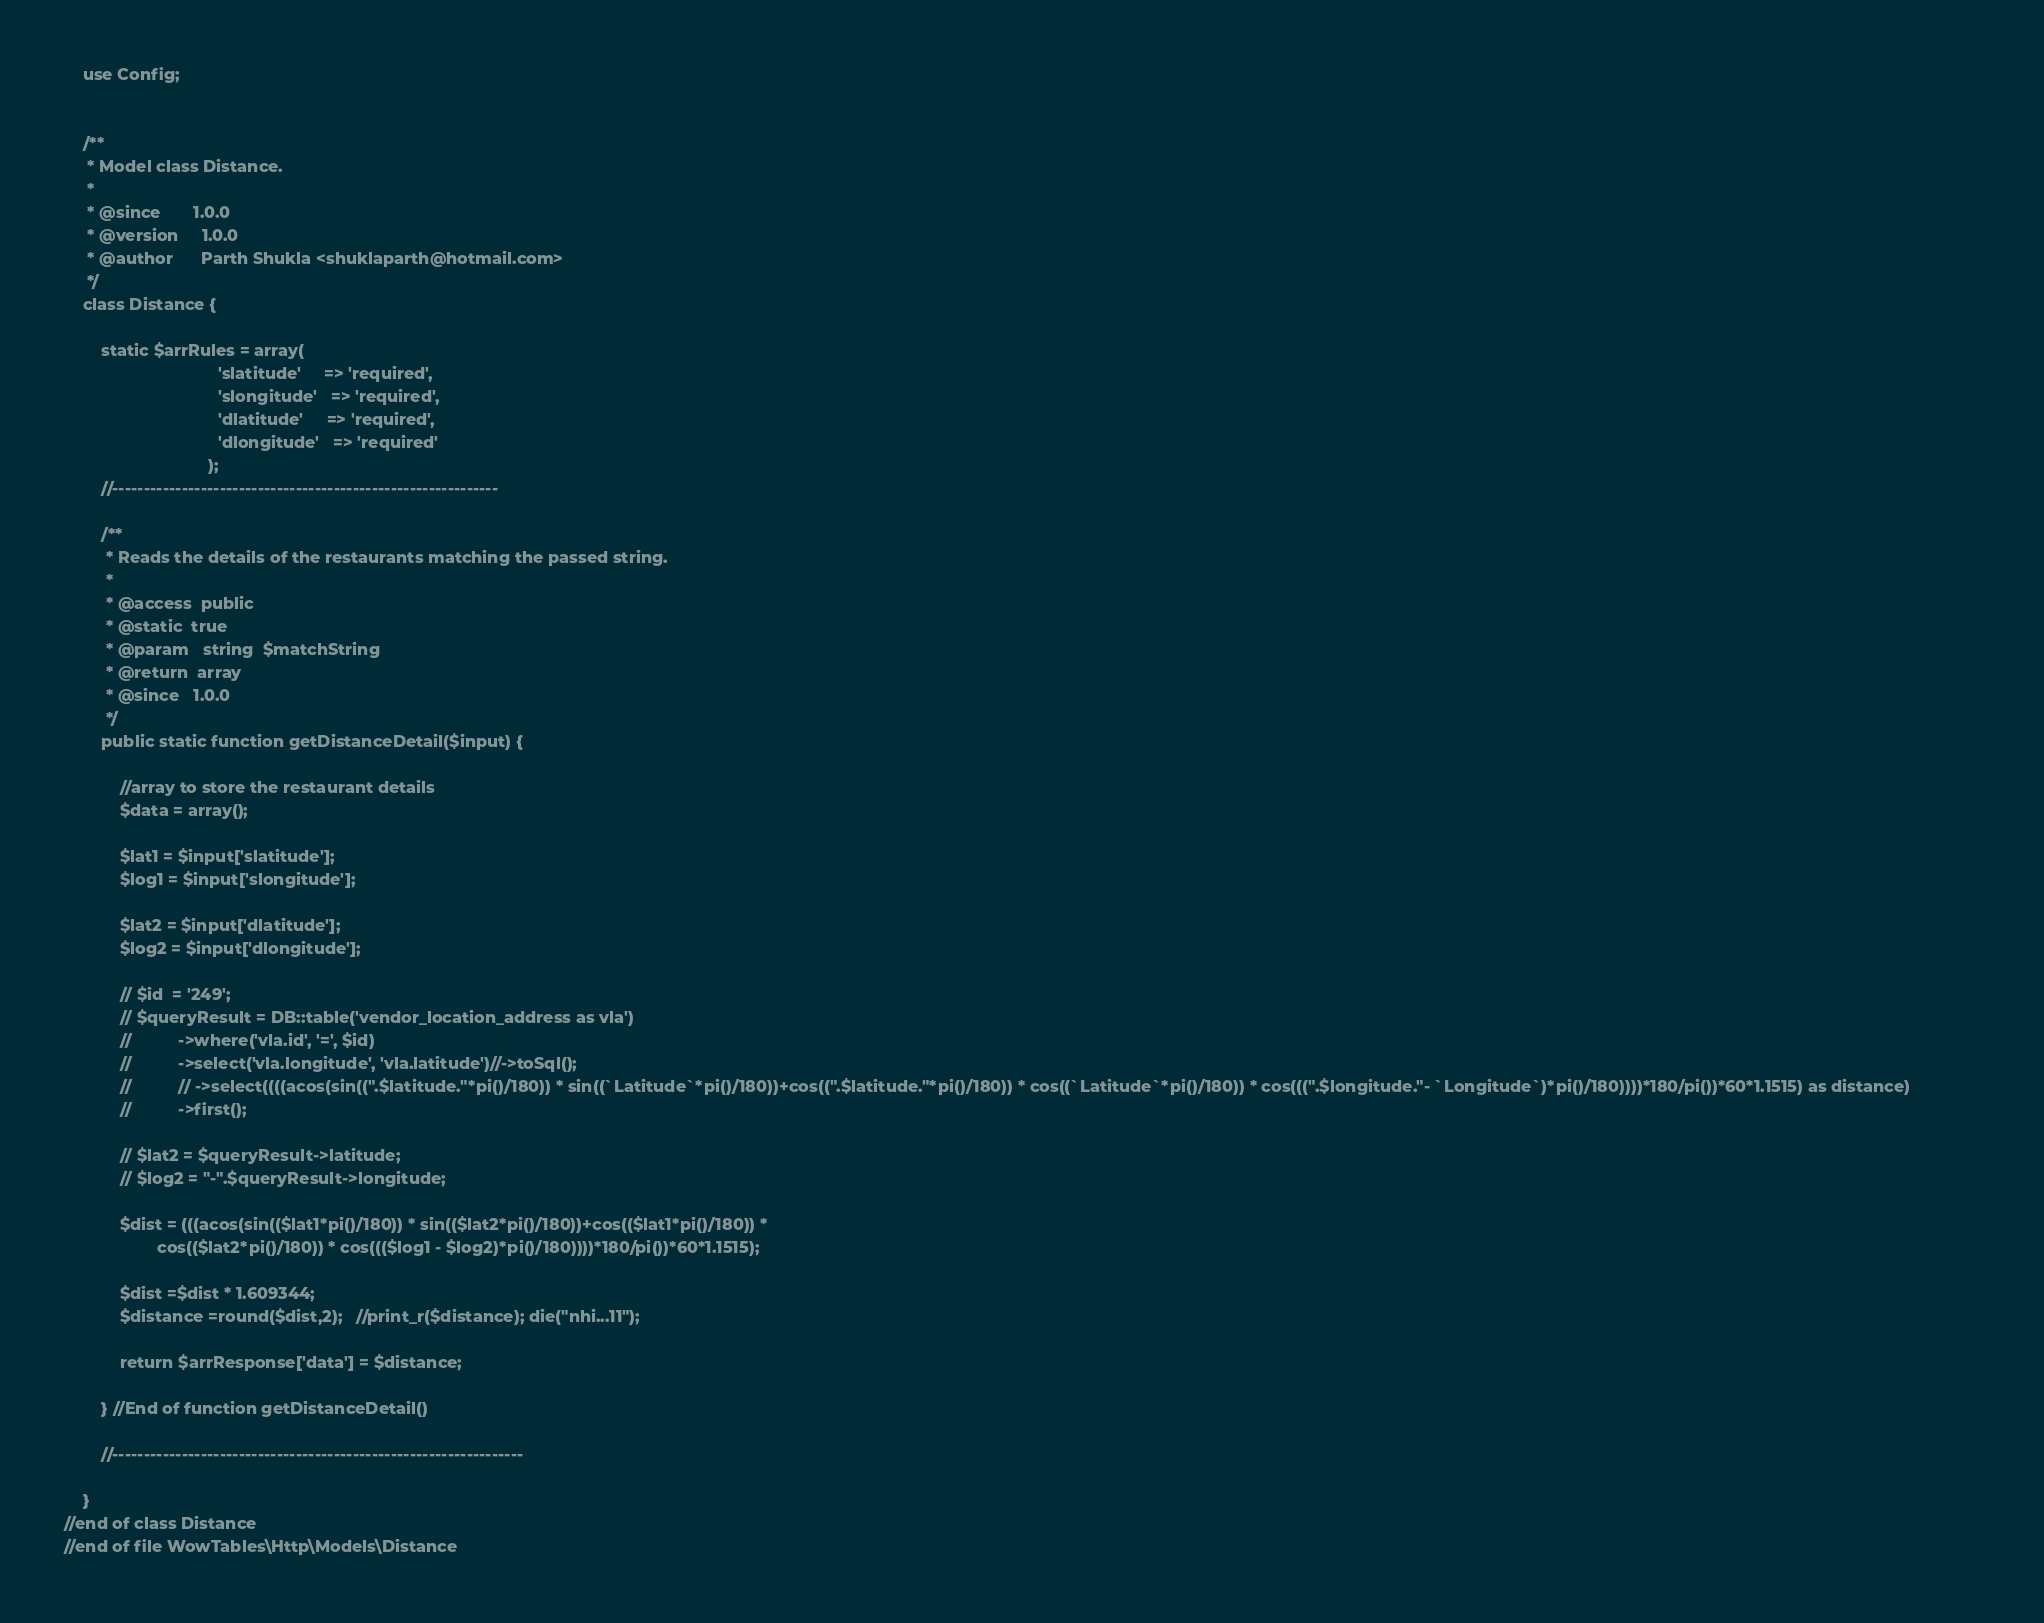Convert code to text. <code><loc_0><loc_0><loc_500><loc_500><_PHP_>	use Config;
	

	/**
	 * Model class Distance.
	 *
	 * @since		1.0.0
	 * @version		1.0.0
	 * @author		Parth Shukla <shuklaparth@hotmail.com>
	 */
	class Distance {

		static $arrRules = array(                            
	                             'slatitude'     => 'required',
	                             'slongitude'  	=> 'required',
	                             'dlatitude'     => 'required',
	                             'dlongitude'  	=> 'required'
	                           );
    	//-------------------------------------------------------------

		/**
		 * Reads the details of the restaurants matching the passed string.
		 * 
		 * @access	public
		 * @static	true
		 * @param	string	$matchString
		 * @return	array
		 * @since	1.0.0
		 */
		public static function getDistanceDetail($input) {
			
			//array to store the restaurant details
			$data = array();

			$lat1 = $input['slatitude'];
			$log1 = $input['slongitude'];

			$lat2 = $input['dlatitude'];
			$log2 = $input['dlongitude'];

			// $id  = '249';
			// $queryResult = DB::table('vendor_location_address as vla')
			// 			->where('vla.id', '=', $id)
			// 			->select('vla.longitude', 'vla.latitude')//->toSql();
			// 			// ->select((((acos(sin((".$latitude."*pi()/180)) * sin((`Latitude`*pi()/180))+cos((".$latitude."*pi()/180)) * cos((`Latitude`*pi()/180)) * cos(((".$longitude."- `Longitude`)*pi()/180))))*180/pi())*60*1.1515) as distance)				
			// 			->first();

			// $lat2 = $queryResult->latitude;
			// $log2 = "-".$queryResult->longitude;
			
			$dist = (((acos(sin(($lat1*pi()/180)) * sin(($lat2*pi()/180))+cos(($lat1*pi()/180)) *
 					cos(($lat2*pi()/180)) * cos((($log1 - $log2)*pi()/180))))*180/pi())*60*1.1515);

			$dist =$dist * 1.609344;
			$distance =round($dist,2);   //print_r($distance); die("nhi...11");

			return $arrResponse['data'] = $distance;

		} //End of function getDistanceDetail()

		//-----------------------------------------------------------------

	}
//end of class Distance
//end of file WowTables\Http\Models\Distance</code> 